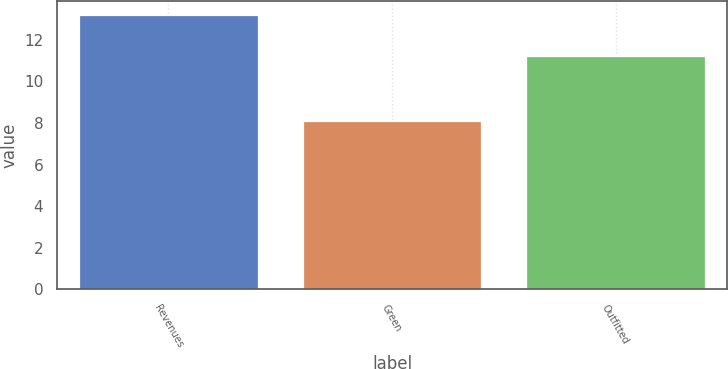<chart> <loc_0><loc_0><loc_500><loc_500><bar_chart><fcel>Revenues<fcel>Green<fcel>Outfitted<nl><fcel>13.2<fcel>8.1<fcel>11.2<nl></chart> 